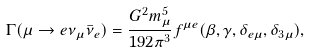<formula> <loc_0><loc_0><loc_500><loc_500>\Gamma ( \mu \to e \nu _ { \mu } \bar { \nu } _ { e } ) = \frac { G ^ { 2 } m ^ { 5 } _ { \mu } } { 1 9 2 \pi ^ { 3 } } f ^ { \mu e } ( \beta , \gamma , \delta _ { e \mu } , \delta _ { 3 \mu } ) ,</formula> 